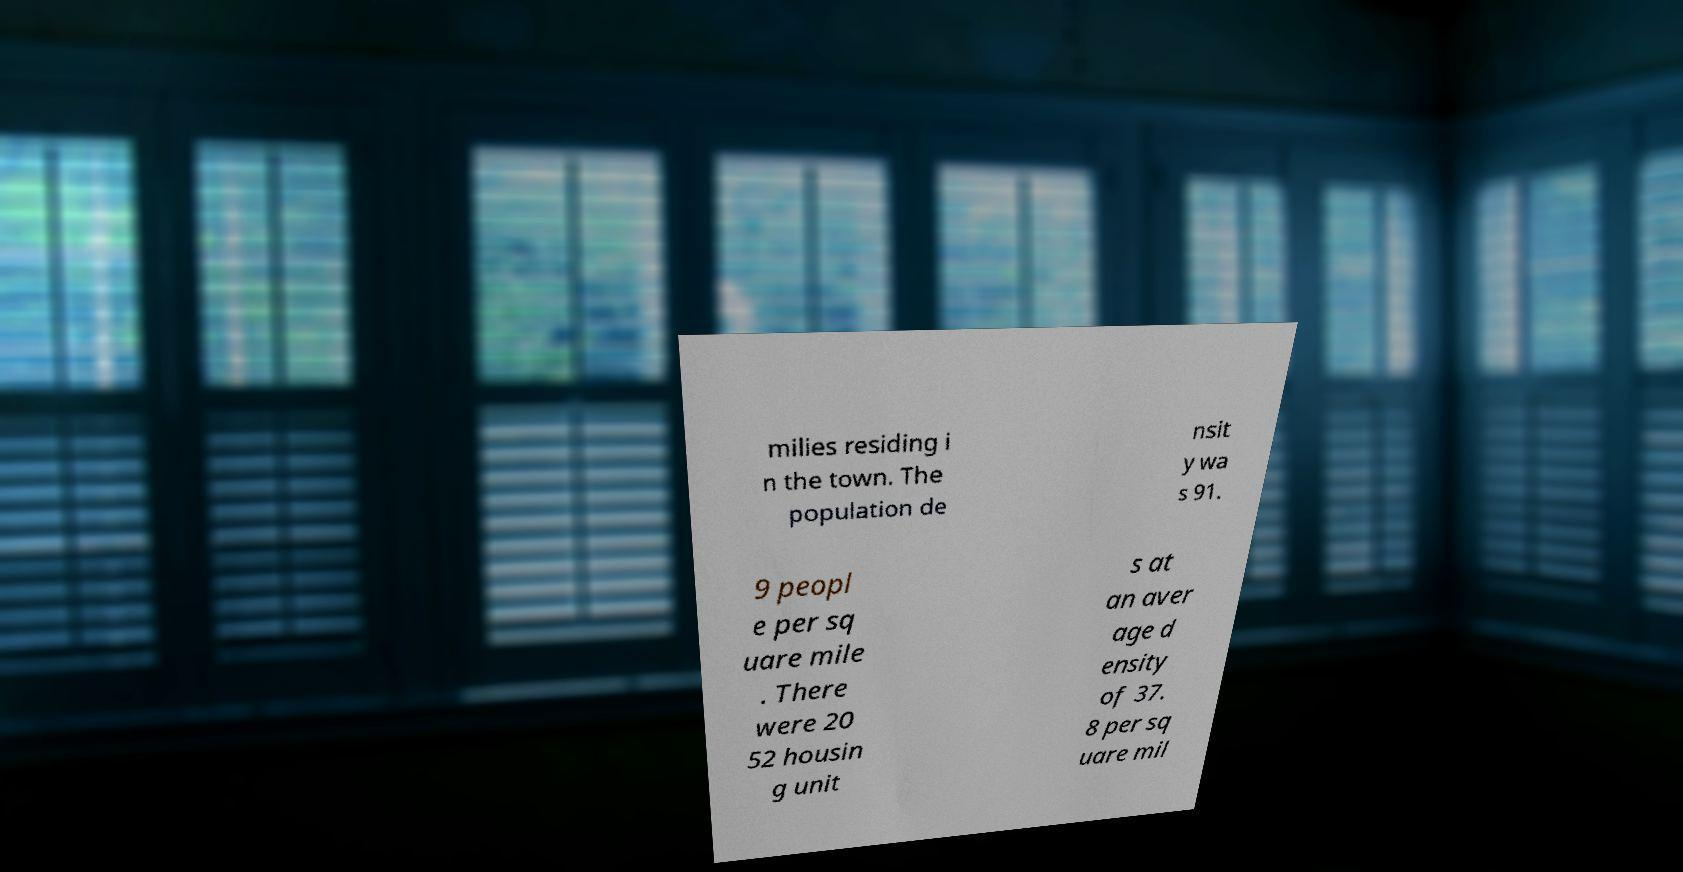Can you accurately transcribe the text from the provided image for me? milies residing i n the town. The population de nsit y wa s 91. 9 peopl e per sq uare mile . There were 20 52 housin g unit s at an aver age d ensity of 37. 8 per sq uare mil 